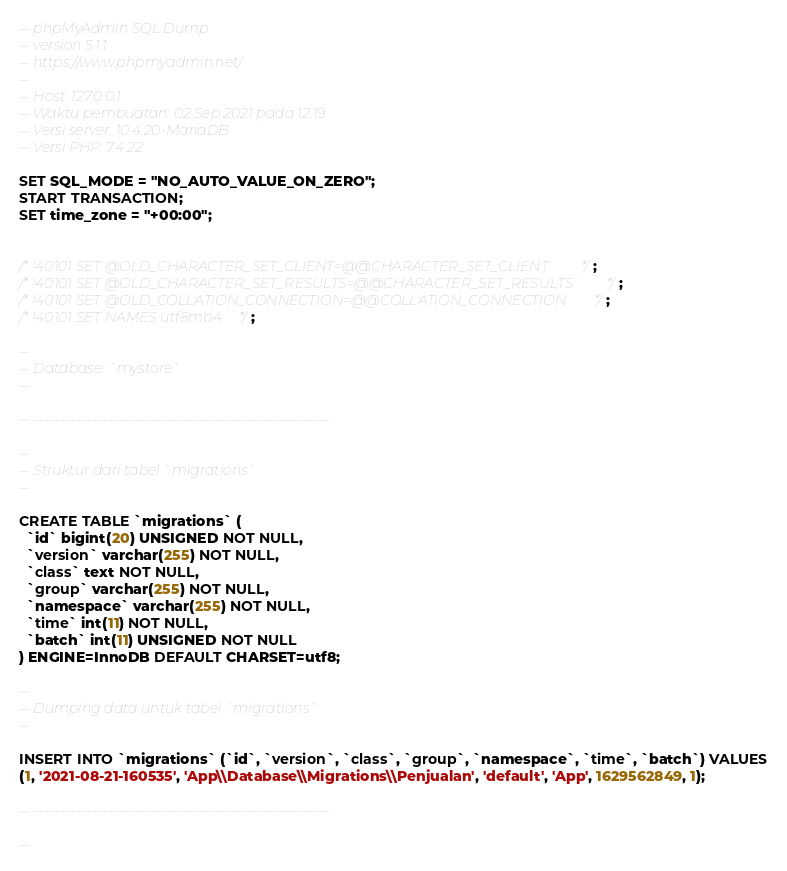<code> <loc_0><loc_0><loc_500><loc_500><_SQL_>-- phpMyAdmin SQL Dump
-- version 5.1.1
-- https://www.phpmyadmin.net/
--
-- Host: 127.0.0.1
-- Waktu pembuatan: 02 Sep 2021 pada 12.19
-- Versi server: 10.4.20-MariaDB
-- Versi PHP: 7.4.22

SET SQL_MODE = "NO_AUTO_VALUE_ON_ZERO";
START TRANSACTION;
SET time_zone = "+00:00";


/*!40101 SET @OLD_CHARACTER_SET_CLIENT=@@CHARACTER_SET_CLIENT */;
/*!40101 SET @OLD_CHARACTER_SET_RESULTS=@@CHARACTER_SET_RESULTS */;
/*!40101 SET @OLD_COLLATION_CONNECTION=@@COLLATION_CONNECTION */;
/*!40101 SET NAMES utf8mb4 */;

--
-- Database: `mystore`
--

-- --------------------------------------------------------

--
-- Struktur dari tabel `migrations`
--

CREATE TABLE `migrations` (
  `id` bigint(20) UNSIGNED NOT NULL,
  `version` varchar(255) NOT NULL,
  `class` text NOT NULL,
  `group` varchar(255) NOT NULL,
  `namespace` varchar(255) NOT NULL,
  `time` int(11) NOT NULL,
  `batch` int(11) UNSIGNED NOT NULL
) ENGINE=InnoDB DEFAULT CHARSET=utf8;

--
-- Dumping data untuk tabel `migrations`
--

INSERT INTO `migrations` (`id`, `version`, `class`, `group`, `namespace`, `time`, `batch`) VALUES
(1, '2021-08-21-160535', 'App\\Database\\Migrations\\Penjualan', 'default', 'App', 1629562849, 1);

-- --------------------------------------------------------

--</code> 